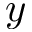Convert formula to latex. <formula><loc_0><loc_0><loc_500><loc_500>y</formula> 